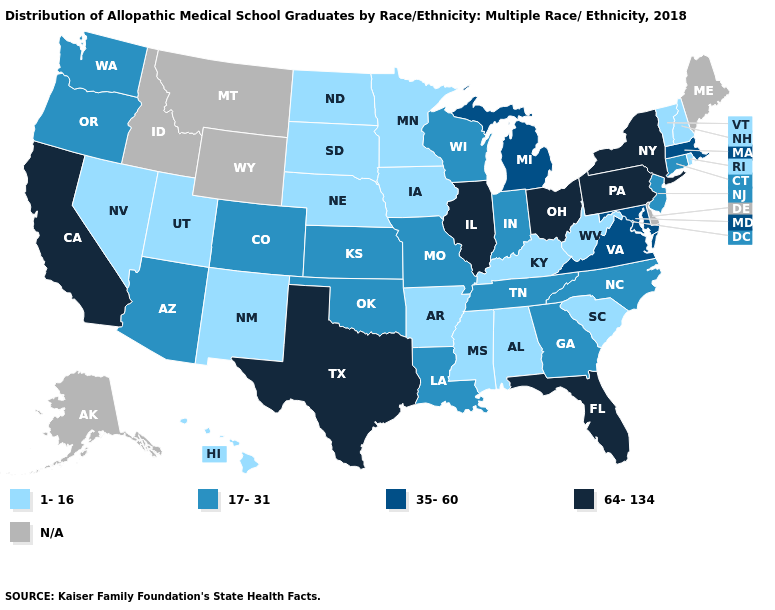Does Massachusetts have the lowest value in the Northeast?
Give a very brief answer. No. Among the states that border Texas , which have the highest value?
Give a very brief answer. Louisiana, Oklahoma. Among the states that border Wyoming , which have the highest value?
Concise answer only. Colorado. What is the value of Colorado?
Quick response, please. 17-31. What is the value of Vermont?
Concise answer only. 1-16. Which states have the lowest value in the USA?
Write a very short answer. Alabama, Arkansas, Hawaii, Iowa, Kentucky, Minnesota, Mississippi, Nebraska, Nevada, New Hampshire, New Mexico, North Dakota, Rhode Island, South Carolina, South Dakota, Utah, Vermont, West Virginia. Which states have the lowest value in the South?
Give a very brief answer. Alabama, Arkansas, Kentucky, Mississippi, South Carolina, West Virginia. Which states hav the highest value in the South?
Answer briefly. Florida, Texas. How many symbols are there in the legend?
Short answer required. 5. What is the lowest value in states that border Wyoming?
Concise answer only. 1-16. Does the map have missing data?
Quick response, please. Yes. Among the states that border California , which have the lowest value?
Concise answer only. Nevada. Which states have the lowest value in the USA?
Be succinct. Alabama, Arkansas, Hawaii, Iowa, Kentucky, Minnesota, Mississippi, Nebraska, Nevada, New Hampshire, New Mexico, North Dakota, Rhode Island, South Carolina, South Dakota, Utah, Vermont, West Virginia. What is the highest value in the MidWest ?
Write a very short answer. 64-134. 